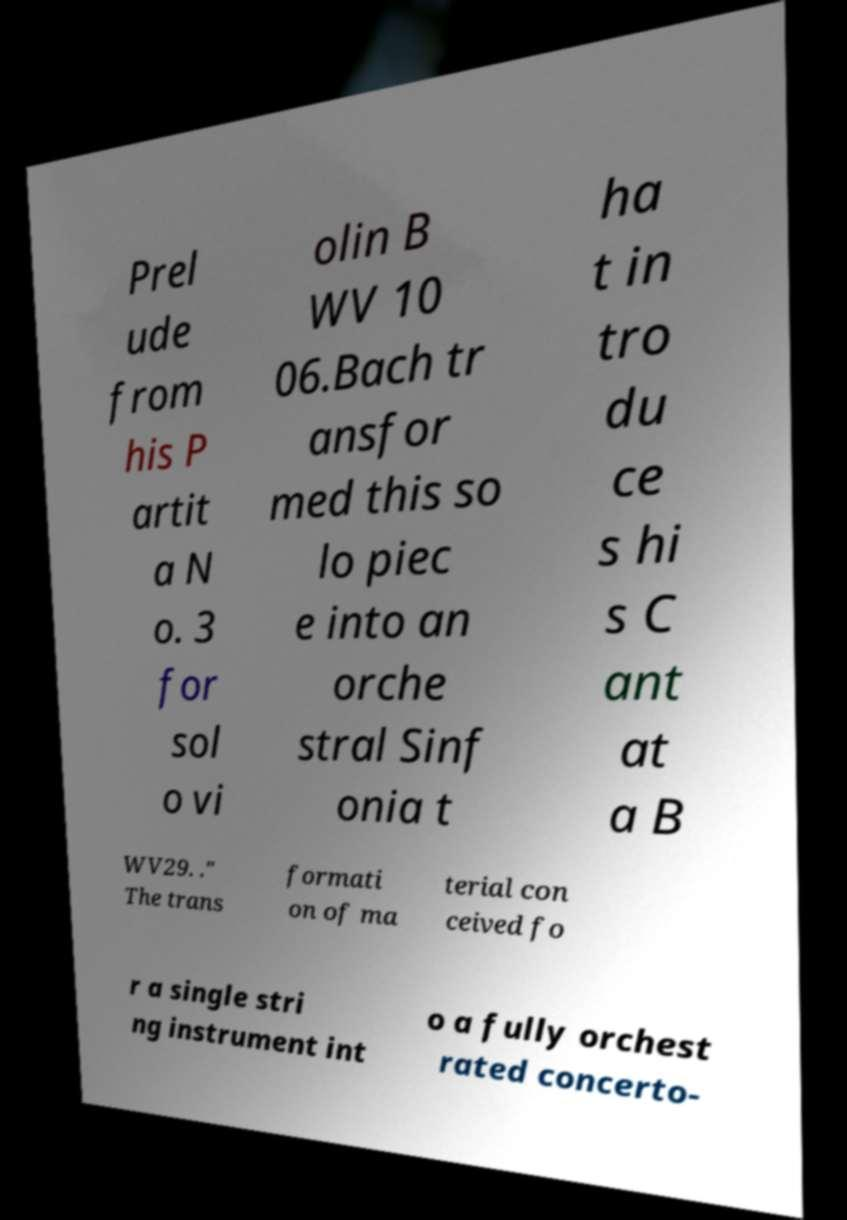There's text embedded in this image that I need extracted. Can you transcribe it verbatim? Prel ude from his P artit a N o. 3 for sol o vi olin B WV 10 06.Bach tr ansfor med this so lo piec e into an orche stral Sinf onia t ha t in tro du ce s hi s C ant at a B WV29. ." The trans formati on of ma terial con ceived fo r a single stri ng instrument int o a fully orchest rated concerto- 